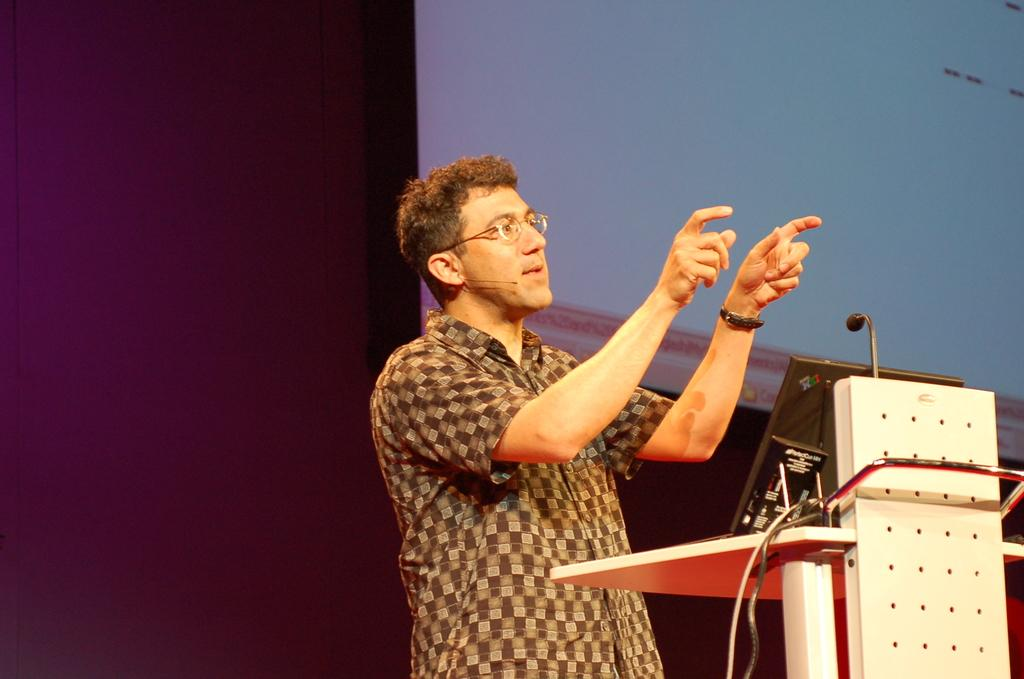Who or what is the main subject in the image? There is a person in the image. What can be observed about the person's appearance? The person is wearing spectacles. What is the person standing in front of? There is a podium in front of the person. What items are present on the podium? There is a device and a microphone in front of the person. What can be seen in the background of the image? There is a projector screen and a wall in the background. What type of drum is the person playing in the image? There is no drum present in the image; the person is standing in front of a podium with a device and a microphone. How many passengers are visible in the image? There are no passengers present in the image; it features a person standing in front of a podium with a device and a microphone. 